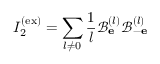Convert formula to latex. <formula><loc_0><loc_0><loc_500><loc_500>I _ { 2 } ^ { ( e x ) } = \sum _ { l \neq 0 } \frac { 1 } { l } \mathcal { B } _ { e } ^ { ( l ) } \mathcal { B } _ { - e } ^ { ( l ) }</formula> 